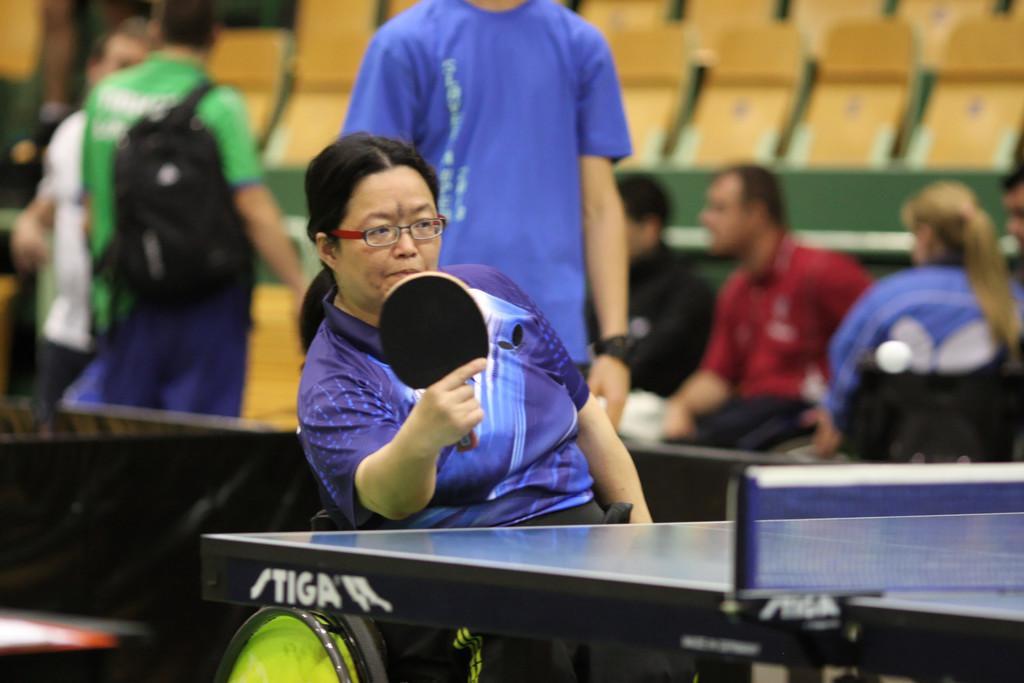Describe this image in one or two sentences. In the image we can see there is a woman who is sitting on chair and holding table tennis racket in her hand and at the back people are standing and sitting and the image is little blue and infront of woman there is net table. 